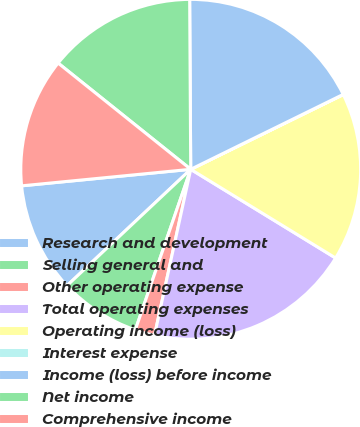Convert chart. <chart><loc_0><loc_0><loc_500><loc_500><pie_chart><fcel>Research and development<fcel>Selling general and<fcel>Other operating expense<fcel>Total operating expenses<fcel>Operating income (loss)<fcel>Interest expense<fcel>Income (loss) before income<fcel>Net income<fcel>Comprehensive income<nl><fcel>10.46%<fcel>7.7%<fcel>1.87%<fcel>19.67%<fcel>15.99%<fcel>0.02%<fcel>17.83%<fcel>14.15%<fcel>12.3%<nl></chart> 